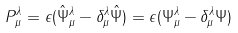<formula> <loc_0><loc_0><loc_500><loc_500>P _ { \mu } ^ { \lambda } = \epsilon ( \hat { \Psi } _ { \mu } ^ { \lambda } - \delta _ { \mu } ^ { \lambda } \hat { \Psi } ) = \epsilon ( \Psi _ { \mu } ^ { \lambda } - \delta _ { \mu } ^ { \lambda } \Psi )</formula> 